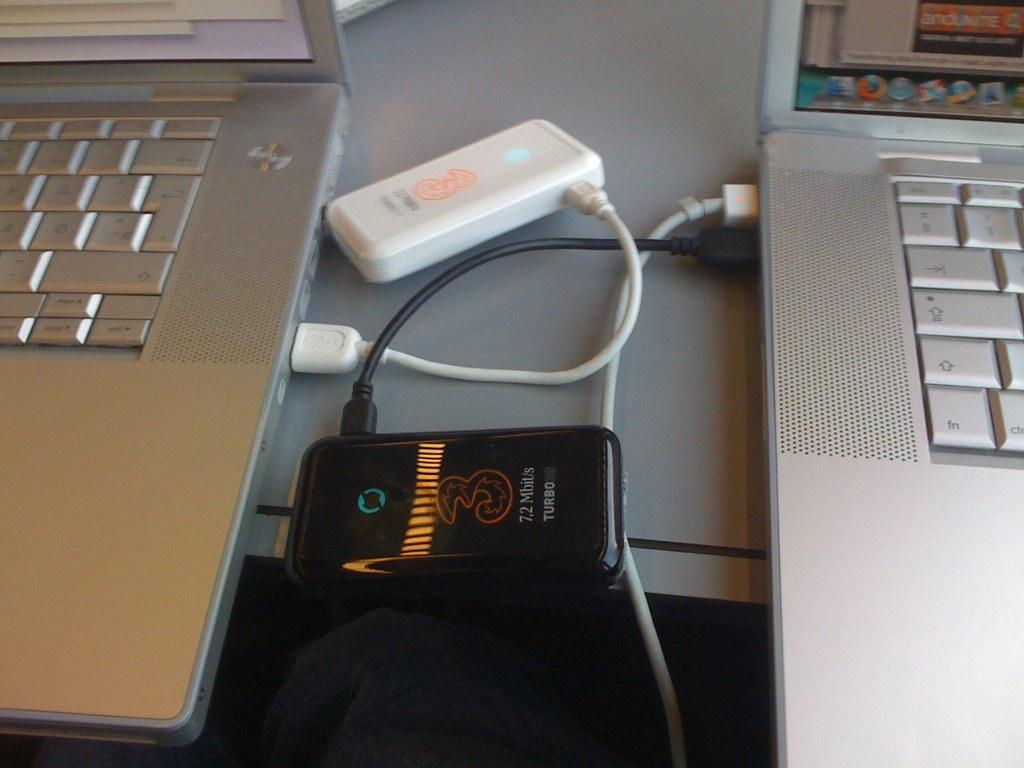<image>
Present a compact description of the photo's key features. Two laptops on a table have cell phones plugged in that say Turbo. 